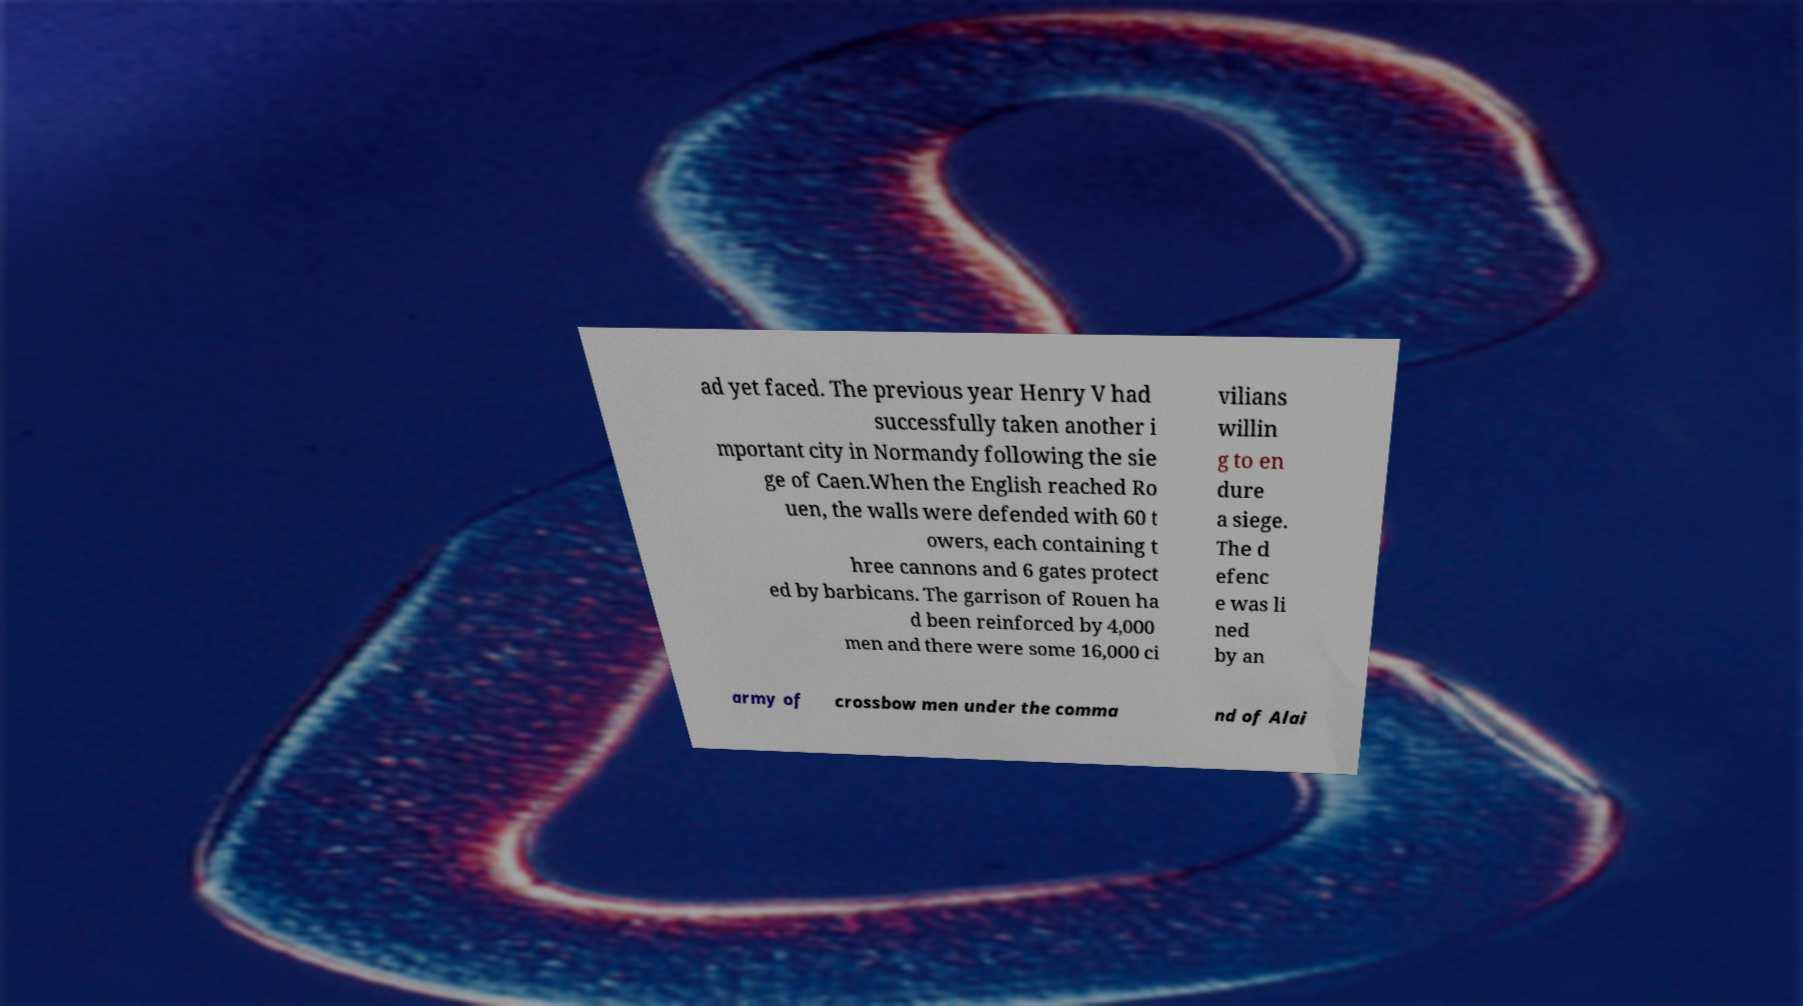Please read and relay the text visible in this image. What does it say? ad yet faced. The previous year Henry V had successfully taken another i mportant city in Normandy following the sie ge of Caen.When the English reached Ro uen, the walls were defended with 60 t owers, each containing t hree cannons and 6 gates protect ed by barbicans. The garrison of Rouen ha d been reinforced by 4,000 men and there were some 16,000 ci vilians willin g to en dure a siege. The d efenc e was li ned by an army of crossbow men under the comma nd of Alai 